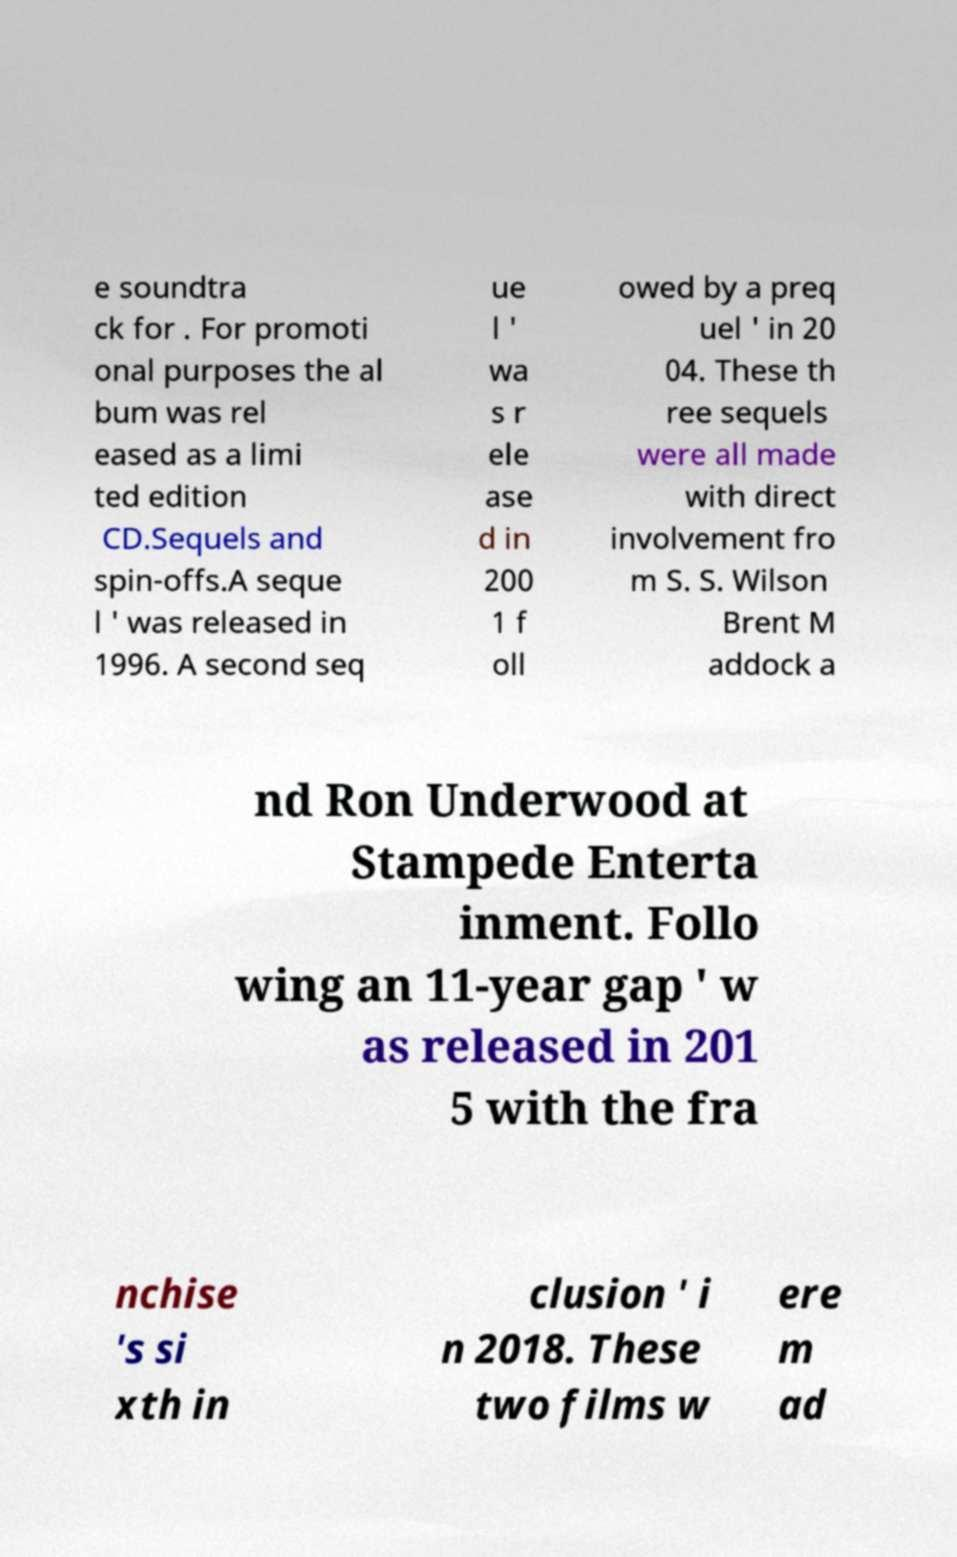For documentation purposes, I need the text within this image transcribed. Could you provide that? e soundtra ck for . For promoti onal purposes the al bum was rel eased as a limi ted edition CD.Sequels and spin-offs.A seque l ' was released in 1996. A second seq ue l ' wa s r ele ase d in 200 1 f oll owed by a preq uel ' in 20 04. These th ree sequels were all made with direct involvement fro m S. S. Wilson Brent M addock a nd Ron Underwood at Stampede Enterta inment. Follo wing an 11-year gap ' w as released in 201 5 with the fra nchise 's si xth in clusion ' i n 2018. These two films w ere m ad 